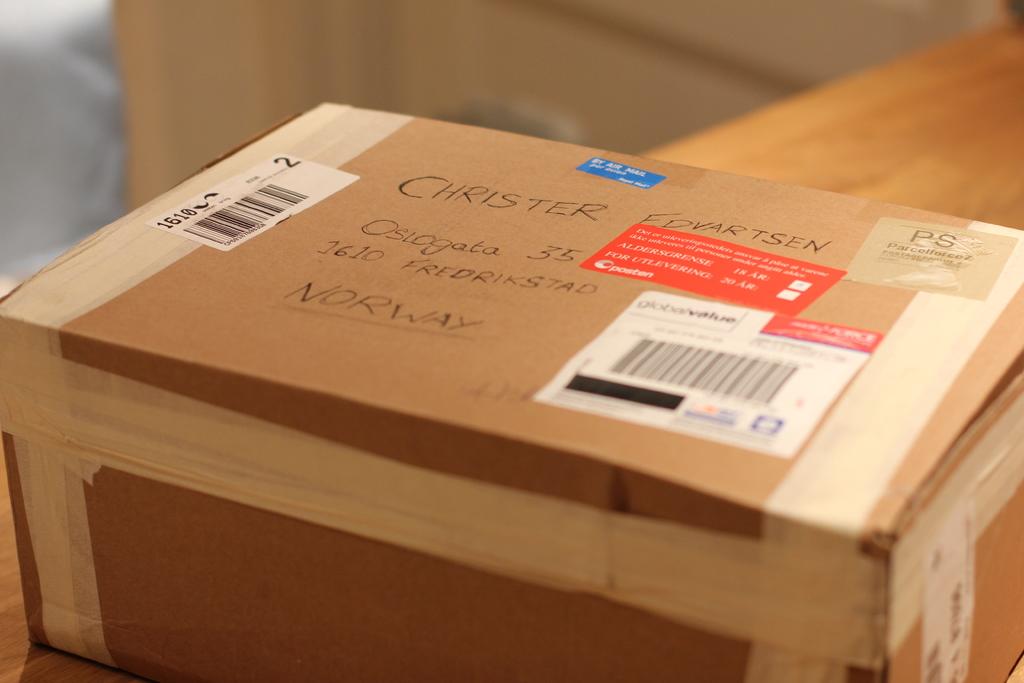Was this sent to or from norway?
Offer a terse response. To. 